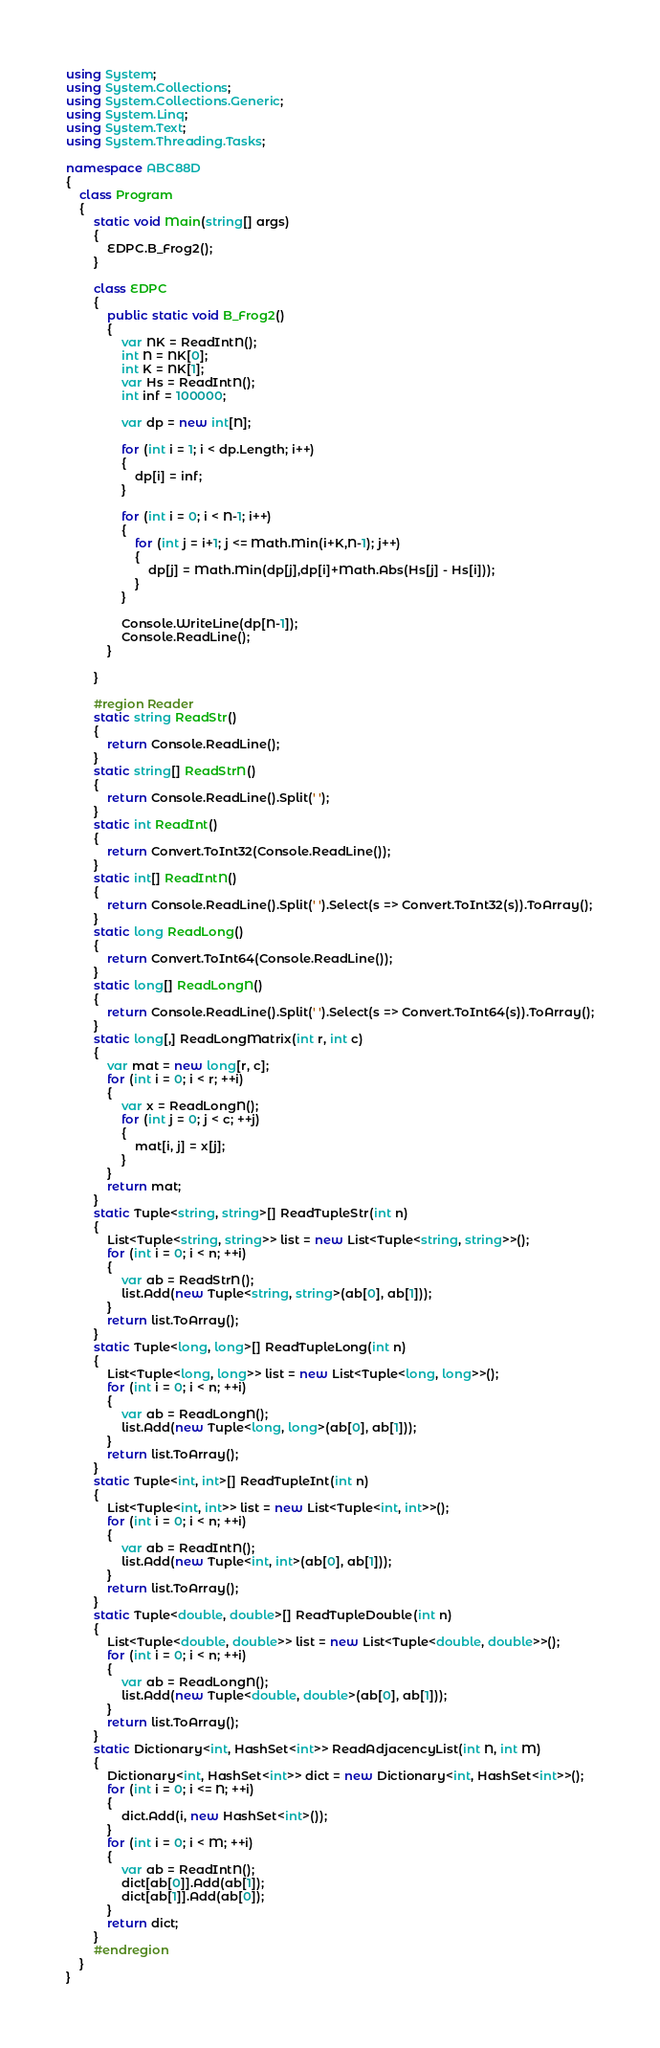Convert code to text. <code><loc_0><loc_0><loc_500><loc_500><_C#_>using System;
using System.Collections;
using System.Collections.Generic;
using System.Linq;
using System.Text;
using System.Threading.Tasks;

namespace ABC88D
{
    class Program
    {
        static void Main(string[] args)
        {
            EDPC.B_Frog2();
        }

        class EDPC
        {
            public static void B_Frog2()
            {
                var NK = ReadIntN();
                int N = NK[0];
                int K = NK[1];
                var Hs = ReadIntN();
                int inf = 100000;

                var dp = new int[N];

                for (int i = 1; i < dp.Length; i++)
                {
                    dp[i] = inf;
                }

                for (int i = 0; i < N-1; i++)
                {
                    for (int j = i+1; j <= Math.Min(i+K,N-1); j++)
                    {
                        dp[j] = Math.Min(dp[j],dp[i]+Math.Abs(Hs[j] - Hs[i]));
                    }
                }

                Console.WriteLine(dp[N-1]);
                Console.ReadLine();
            }

        }

        #region Reader
        static string ReadStr()
        {
            return Console.ReadLine();
        }
        static string[] ReadStrN()
        {
            return Console.ReadLine().Split(' ');
        }
        static int ReadInt()
        {
            return Convert.ToInt32(Console.ReadLine());
        }
        static int[] ReadIntN()
        {
            return Console.ReadLine().Split(' ').Select(s => Convert.ToInt32(s)).ToArray();
        }
        static long ReadLong()
        {
            return Convert.ToInt64(Console.ReadLine());
        }
        static long[] ReadLongN()
        {
            return Console.ReadLine().Split(' ').Select(s => Convert.ToInt64(s)).ToArray();
        }
        static long[,] ReadLongMatrix(int r, int c)
        {
            var mat = new long[r, c];
            for (int i = 0; i < r; ++i)
            {
                var x = ReadLongN();
                for (int j = 0; j < c; ++j)
                {
                    mat[i, j] = x[j];
                }
            }
            return mat;
        }
        static Tuple<string, string>[] ReadTupleStr(int n)
        {
            List<Tuple<string, string>> list = new List<Tuple<string, string>>();
            for (int i = 0; i < n; ++i)
            {
                var ab = ReadStrN();
                list.Add(new Tuple<string, string>(ab[0], ab[1]));
            }
            return list.ToArray();
        }
        static Tuple<long, long>[] ReadTupleLong(int n)
        {
            List<Tuple<long, long>> list = new List<Tuple<long, long>>();
            for (int i = 0; i < n; ++i)
            {
                var ab = ReadLongN();
                list.Add(new Tuple<long, long>(ab[0], ab[1]));
            }
            return list.ToArray();
        }
        static Tuple<int, int>[] ReadTupleInt(int n)
        {
            List<Tuple<int, int>> list = new List<Tuple<int, int>>();
            for (int i = 0; i < n; ++i)
            {
                var ab = ReadIntN();
                list.Add(new Tuple<int, int>(ab[0], ab[1]));
            }
            return list.ToArray();
        }
        static Tuple<double, double>[] ReadTupleDouble(int n)
        {
            List<Tuple<double, double>> list = new List<Tuple<double, double>>();
            for (int i = 0; i < n; ++i)
            {
                var ab = ReadLongN();
                list.Add(new Tuple<double, double>(ab[0], ab[1]));
            }
            return list.ToArray();
        }
        static Dictionary<int, HashSet<int>> ReadAdjacencyList(int N, int M)
        {
            Dictionary<int, HashSet<int>> dict = new Dictionary<int, HashSet<int>>();
            for (int i = 0; i <= N; ++i)
            {
                dict.Add(i, new HashSet<int>());
            }
            for (int i = 0; i < M; ++i)
            {
                var ab = ReadIntN();
                dict[ab[0]].Add(ab[1]);
                dict[ab[1]].Add(ab[0]);
            }
            return dict;
        }
        #endregion
    }
}
</code> 